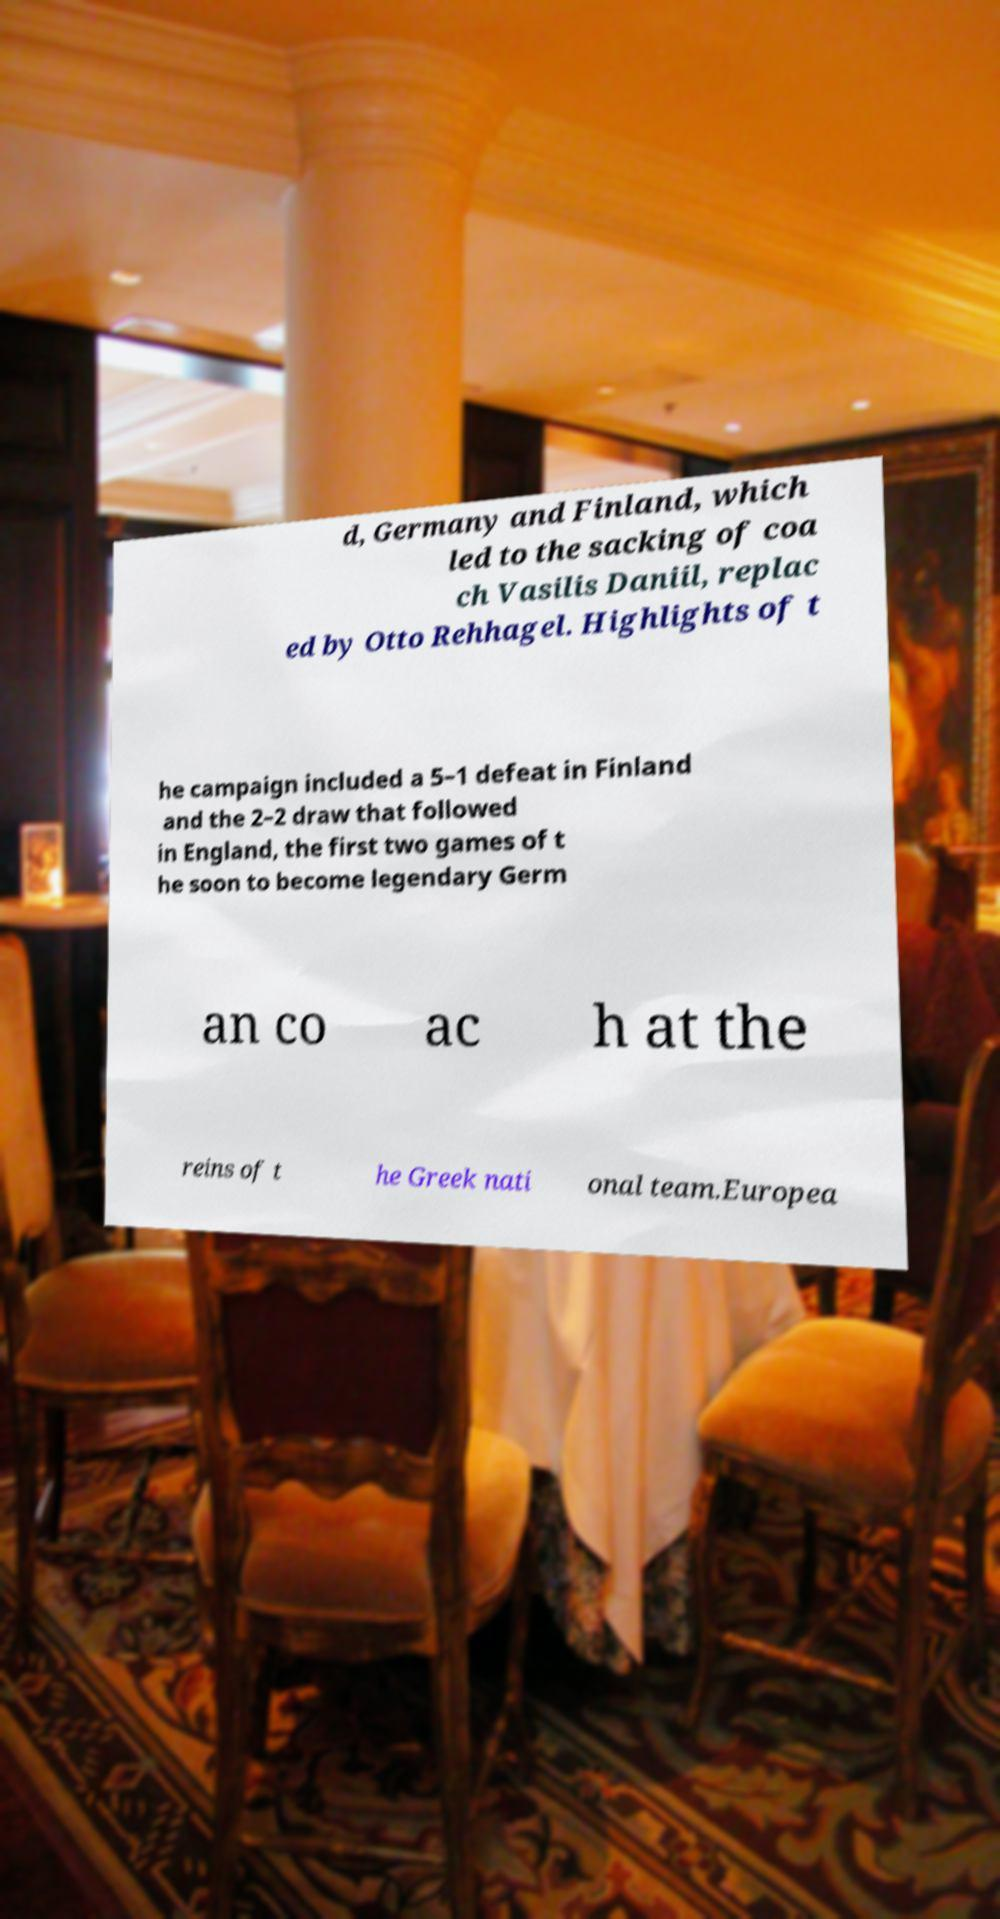Please read and relay the text visible in this image. What does it say? d, Germany and Finland, which led to the sacking of coa ch Vasilis Daniil, replac ed by Otto Rehhagel. Highlights of t he campaign included a 5–1 defeat in Finland and the 2–2 draw that followed in England, the first two games of t he soon to become legendary Germ an co ac h at the reins of t he Greek nati onal team.Europea 